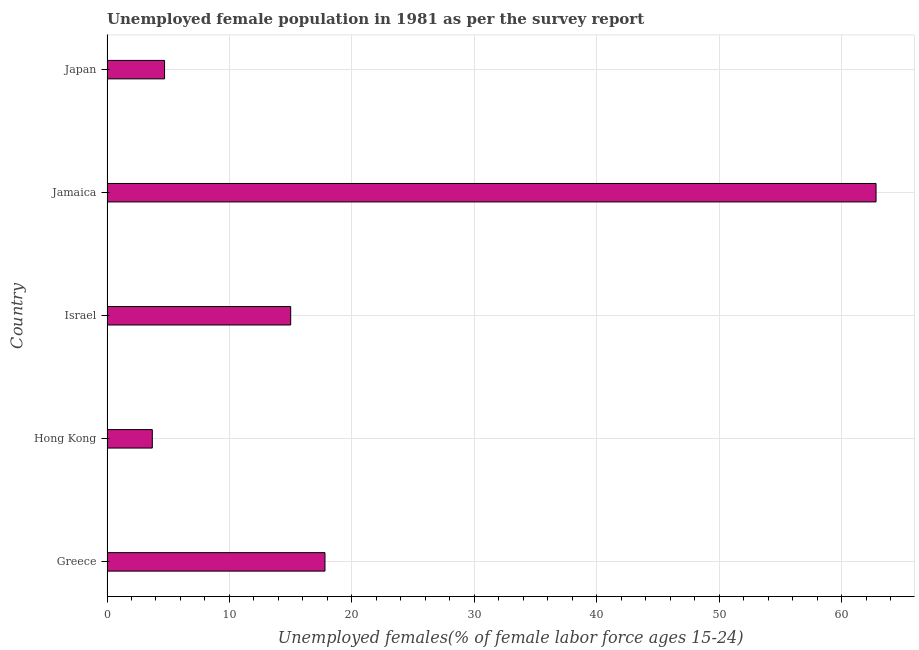What is the title of the graph?
Give a very brief answer. Unemployed female population in 1981 as per the survey report. What is the label or title of the X-axis?
Provide a succinct answer. Unemployed females(% of female labor force ages 15-24). What is the label or title of the Y-axis?
Offer a terse response. Country. What is the unemployed female youth in Jamaica?
Give a very brief answer. 62.8. Across all countries, what is the maximum unemployed female youth?
Keep it short and to the point. 62.8. Across all countries, what is the minimum unemployed female youth?
Make the answer very short. 3.7. In which country was the unemployed female youth maximum?
Provide a succinct answer. Jamaica. In which country was the unemployed female youth minimum?
Provide a short and direct response. Hong Kong. What is the sum of the unemployed female youth?
Offer a very short reply. 104. What is the average unemployed female youth per country?
Your response must be concise. 20.8. What is the ratio of the unemployed female youth in Greece to that in Japan?
Offer a terse response. 3.79. Is the unemployed female youth in Hong Kong less than that in Israel?
Offer a very short reply. Yes. What is the difference between the highest and the second highest unemployed female youth?
Give a very brief answer. 45. Is the sum of the unemployed female youth in Greece and Hong Kong greater than the maximum unemployed female youth across all countries?
Keep it short and to the point. No. What is the difference between the highest and the lowest unemployed female youth?
Ensure brevity in your answer.  59.1. What is the Unemployed females(% of female labor force ages 15-24) in Greece?
Give a very brief answer. 17.8. What is the Unemployed females(% of female labor force ages 15-24) in Hong Kong?
Your answer should be compact. 3.7. What is the Unemployed females(% of female labor force ages 15-24) of Israel?
Your response must be concise. 15. What is the Unemployed females(% of female labor force ages 15-24) of Jamaica?
Your answer should be very brief. 62.8. What is the Unemployed females(% of female labor force ages 15-24) of Japan?
Your answer should be compact. 4.7. What is the difference between the Unemployed females(% of female labor force ages 15-24) in Greece and Israel?
Provide a succinct answer. 2.8. What is the difference between the Unemployed females(% of female labor force ages 15-24) in Greece and Jamaica?
Offer a very short reply. -45. What is the difference between the Unemployed females(% of female labor force ages 15-24) in Greece and Japan?
Provide a short and direct response. 13.1. What is the difference between the Unemployed females(% of female labor force ages 15-24) in Hong Kong and Israel?
Offer a very short reply. -11.3. What is the difference between the Unemployed females(% of female labor force ages 15-24) in Hong Kong and Jamaica?
Your answer should be compact. -59.1. What is the difference between the Unemployed females(% of female labor force ages 15-24) in Hong Kong and Japan?
Your answer should be compact. -1. What is the difference between the Unemployed females(% of female labor force ages 15-24) in Israel and Jamaica?
Ensure brevity in your answer.  -47.8. What is the difference between the Unemployed females(% of female labor force ages 15-24) in Jamaica and Japan?
Provide a short and direct response. 58.1. What is the ratio of the Unemployed females(% of female labor force ages 15-24) in Greece to that in Hong Kong?
Provide a succinct answer. 4.81. What is the ratio of the Unemployed females(% of female labor force ages 15-24) in Greece to that in Israel?
Give a very brief answer. 1.19. What is the ratio of the Unemployed females(% of female labor force ages 15-24) in Greece to that in Jamaica?
Provide a short and direct response. 0.28. What is the ratio of the Unemployed females(% of female labor force ages 15-24) in Greece to that in Japan?
Give a very brief answer. 3.79. What is the ratio of the Unemployed females(% of female labor force ages 15-24) in Hong Kong to that in Israel?
Offer a very short reply. 0.25. What is the ratio of the Unemployed females(% of female labor force ages 15-24) in Hong Kong to that in Jamaica?
Provide a succinct answer. 0.06. What is the ratio of the Unemployed females(% of female labor force ages 15-24) in Hong Kong to that in Japan?
Offer a very short reply. 0.79. What is the ratio of the Unemployed females(% of female labor force ages 15-24) in Israel to that in Jamaica?
Provide a succinct answer. 0.24. What is the ratio of the Unemployed females(% of female labor force ages 15-24) in Israel to that in Japan?
Give a very brief answer. 3.19. What is the ratio of the Unemployed females(% of female labor force ages 15-24) in Jamaica to that in Japan?
Offer a terse response. 13.36. 